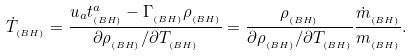<formula> <loc_0><loc_0><loc_500><loc_500>\dot { T } _ { _ { \left ( B H \right ) } } = \frac { u _ { a } t _ { _ { \left ( B H \right ) } } ^ { a } - \Gamma _ { _ { \left ( B H \right ) } } \rho _ { _ { \left ( B H \right ) } } } { \partial \rho _ { _ { \left ( B H \right ) } } / \partial T _ { _ { \left ( B H \right ) } } } = \frac { \rho _ { _ { \left ( B H \right ) } } } { \partial \rho _ { _ { \left ( B H \right ) } } / \partial T _ { _ { \left ( B H \right ) } } } \frac { \dot { m } _ { _ { \left ( B H \right ) } } } { m _ { _ { \left ( B H \right ) } } } { . }</formula> 